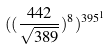<formula> <loc_0><loc_0><loc_500><loc_500>( ( \frac { 4 4 2 } { \sqrt { 3 8 9 } } ) ^ { 8 } ) ^ { 3 9 5 ^ { 1 } }</formula> 